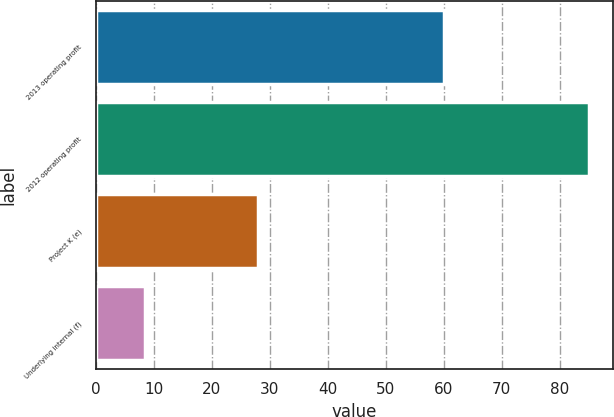<chart> <loc_0><loc_0><loc_500><loc_500><bar_chart><fcel>2013 operating profit<fcel>2012 operating profit<fcel>Project K (e)<fcel>Underlying internal (f)<nl><fcel>60<fcel>85<fcel>27.9<fcel>8.4<nl></chart> 